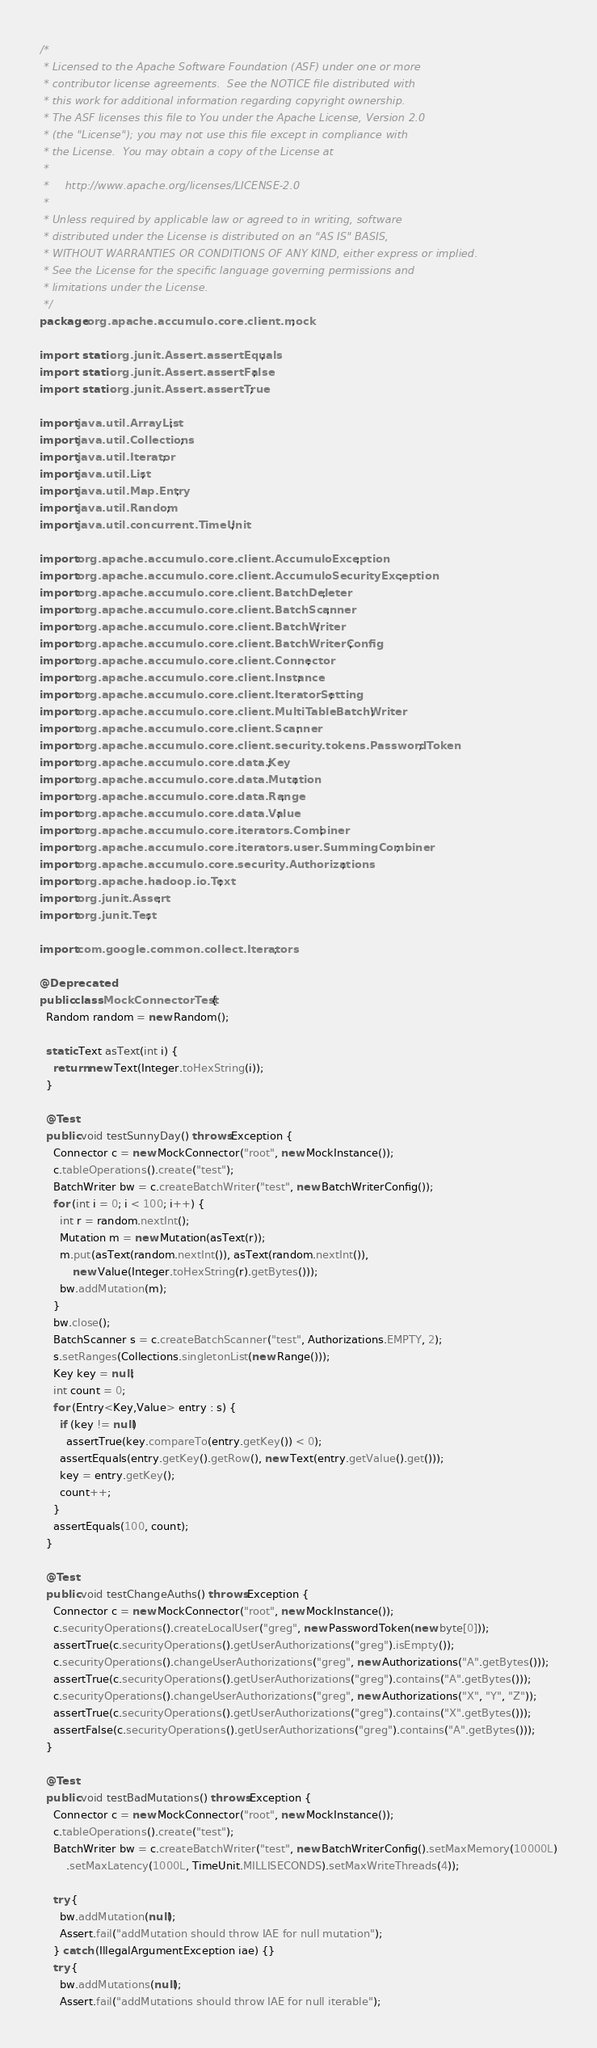Convert code to text. <code><loc_0><loc_0><loc_500><loc_500><_Java_>/*
 * Licensed to the Apache Software Foundation (ASF) under one or more
 * contributor license agreements.  See the NOTICE file distributed with
 * this work for additional information regarding copyright ownership.
 * The ASF licenses this file to You under the Apache License, Version 2.0
 * (the "License"); you may not use this file except in compliance with
 * the License.  You may obtain a copy of the License at
 *
 *     http://www.apache.org/licenses/LICENSE-2.0
 *
 * Unless required by applicable law or agreed to in writing, software
 * distributed under the License is distributed on an "AS IS" BASIS,
 * WITHOUT WARRANTIES OR CONDITIONS OF ANY KIND, either express or implied.
 * See the License for the specific language governing permissions and
 * limitations under the License.
 */
package org.apache.accumulo.core.client.mock;

import static org.junit.Assert.assertEquals;
import static org.junit.Assert.assertFalse;
import static org.junit.Assert.assertTrue;

import java.util.ArrayList;
import java.util.Collections;
import java.util.Iterator;
import java.util.List;
import java.util.Map.Entry;
import java.util.Random;
import java.util.concurrent.TimeUnit;

import org.apache.accumulo.core.client.AccumuloException;
import org.apache.accumulo.core.client.AccumuloSecurityException;
import org.apache.accumulo.core.client.BatchDeleter;
import org.apache.accumulo.core.client.BatchScanner;
import org.apache.accumulo.core.client.BatchWriter;
import org.apache.accumulo.core.client.BatchWriterConfig;
import org.apache.accumulo.core.client.Connector;
import org.apache.accumulo.core.client.Instance;
import org.apache.accumulo.core.client.IteratorSetting;
import org.apache.accumulo.core.client.MultiTableBatchWriter;
import org.apache.accumulo.core.client.Scanner;
import org.apache.accumulo.core.client.security.tokens.PasswordToken;
import org.apache.accumulo.core.data.Key;
import org.apache.accumulo.core.data.Mutation;
import org.apache.accumulo.core.data.Range;
import org.apache.accumulo.core.data.Value;
import org.apache.accumulo.core.iterators.Combiner;
import org.apache.accumulo.core.iterators.user.SummingCombiner;
import org.apache.accumulo.core.security.Authorizations;
import org.apache.hadoop.io.Text;
import org.junit.Assert;
import org.junit.Test;

import com.google.common.collect.Iterators;

@Deprecated
public class MockConnectorTest {
  Random random = new Random();

  static Text asText(int i) {
    return new Text(Integer.toHexString(i));
  }

  @Test
  public void testSunnyDay() throws Exception {
    Connector c = new MockConnector("root", new MockInstance());
    c.tableOperations().create("test");
    BatchWriter bw = c.createBatchWriter("test", new BatchWriterConfig());
    for (int i = 0; i < 100; i++) {
      int r = random.nextInt();
      Mutation m = new Mutation(asText(r));
      m.put(asText(random.nextInt()), asText(random.nextInt()),
          new Value(Integer.toHexString(r).getBytes()));
      bw.addMutation(m);
    }
    bw.close();
    BatchScanner s = c.createBatchScanner("test", Authorizations.EMPTY, 2);
    s.setRanges(Collections.singletonList(new Range()));
    Key key = null;
    int count = 0;
    for (Entry<Key,Value> entry : s) {
      if (key != null)
        assertTrue(key.compareTo(entry.getKey()) < 0);
      assertEquals(entry.getKey().getRow(), new Text(entry.getValue().get()));
      key = entry.getKey();
      count++;
    }
    assertEquals(100, count);
  }

  @Test
  public void testChangeAuths() throws Exception {
    Connector c = new MockConnector("root", new MockInstance());
    c.securityOperations().createLocalUser("greg", new PasswordToken(new byte[0]));
    assertTrue(c.securityOperations().getUserAuthorizations("greg").isEmpty());
    c.securityOperations().changeUserAuthorizations("greg", new Authorizations("A".getBytes()));
    assertTrue(c.securityOperations().getUserAuthorizations("greg").contains("A".getBytes()));
    c.securityOperations().changeUserAuthorizations("greg", new Authorizations("X", "Y", "Z"));
    assertTrue(c.securityOperations().getUserAuthorizations("greg").contains("X".getBytes()));
    assertFalse(c.securityOperations().getUserAuthorizations("greg").contains("A".getBytes()));
  }

  @Test
  public void testBadMutations() throws Exception {
    Connector c = new MockConnector("root", new MockInstance());
    c.tableOperations().create("test");
    BatchWriter bw = c.createBatchWriter("test", new BatchWriterConfig().setMaxMemory(10000L)
        .setMaxLatency(1000L, TimeUnit.MILLISECONDS).setMaxWriteThreads(4));

    try {
      bw.addMutation(null);
      Assert.fail("addMutation should throw IAE for null mutation");
    } catch (IllegalArgumentException iae) {}
    try {
      bw.addMutations(null);
      Assert.fail("addMutations should throw IAE for null iterable");</code> 